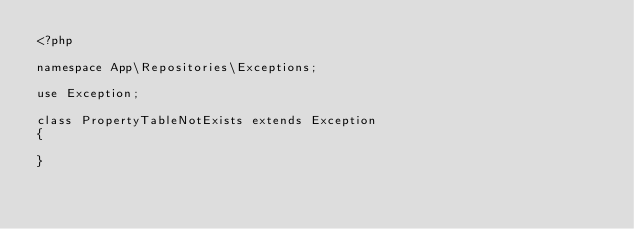<code> <loc_0><loc_0><loc_500><loc_500><_PHP_><?php

namespace App\Repositories\Exceptions;

use Exception;

class PropertyTableNotExists extends Exception
{
    
}
</code> 